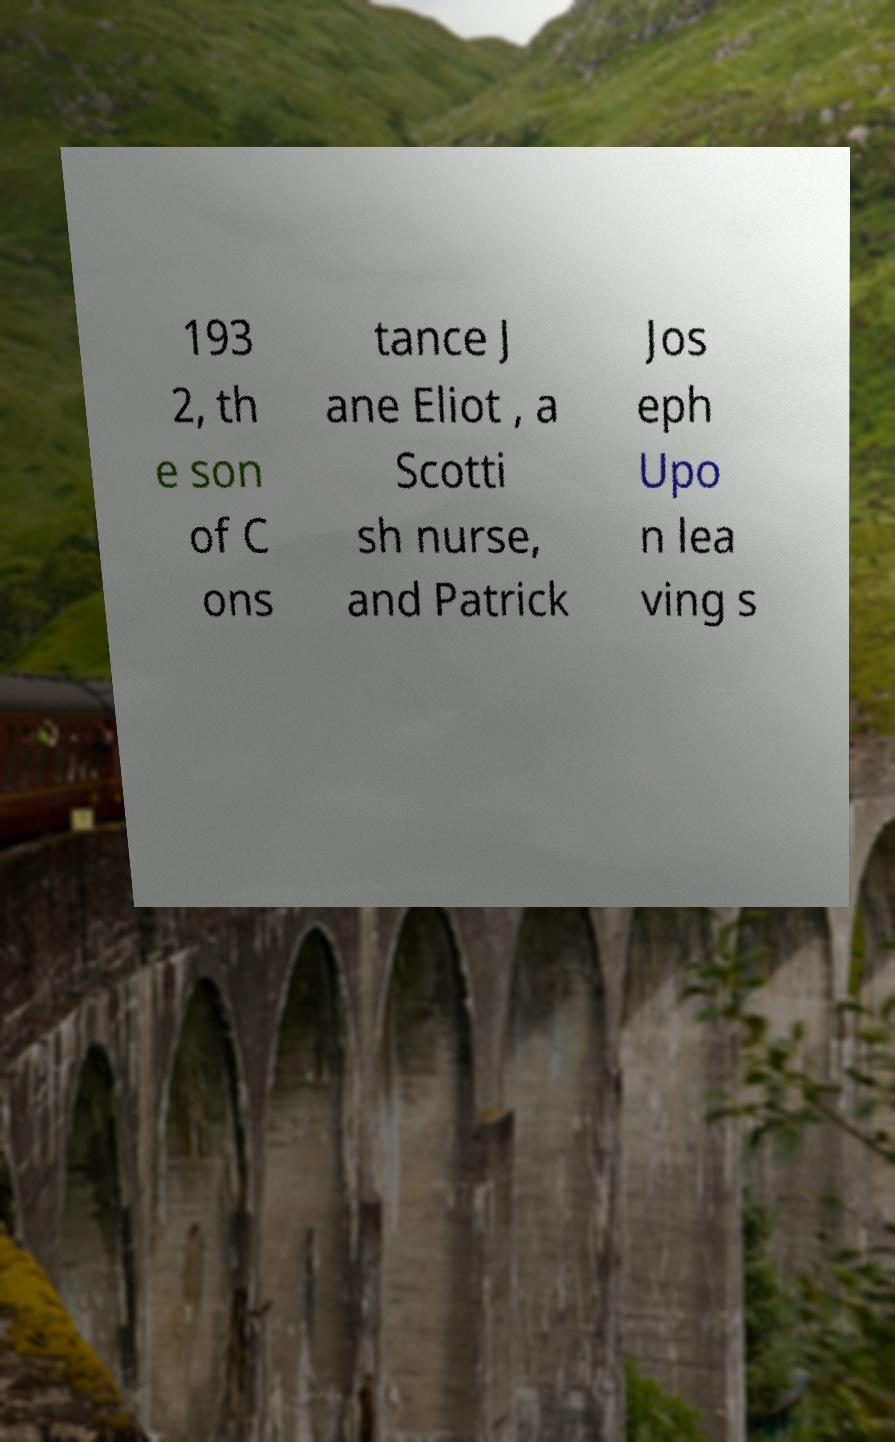For documentation purposes, I need the text within this image transcribed. Could you provide that? 193 2, th e son of C ons tance J ane Eliot , a Scotti sh nurse, and Patrick Jos eph Upo n lea ving s 